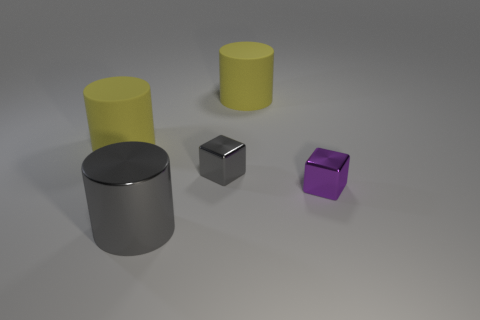What shape is the large thing that is behind the gray cylinder and on the left side of the tiny gray object?
Your answer should be compact. Cylinder. Are there more large yellow blocks than yellow objects?
Give a very brief answer. No. What is the material of the small gray thing?
Ensure brevity in your answer.  Metal. Is there any other thing that is the same size as the purple thing?
Provide a succinct answer. Yes. The other thing that is the same shape as the small purple object is what size?
Offer a terse response. Small. There is a block that is in front of the gray cube; are there any tiny metallic objects to the right of it?
Keep it short and to the point. No. How many other objects are the same shape as the purple metallic object?
Your answer should be compact. 1. Are there more gray things behind the gray metallic cube than gray cylinders behind the metal cylinder?
Keep it short and to the point. No. Is the size of the rubber cylinder to the right of the small gray metallic cube the same as the cylinder that is in front of the small purple metallic block?
Offer a terse response. Yes. The large gray metal object has what shape?
Provide a short and direct response. Cylinder. 